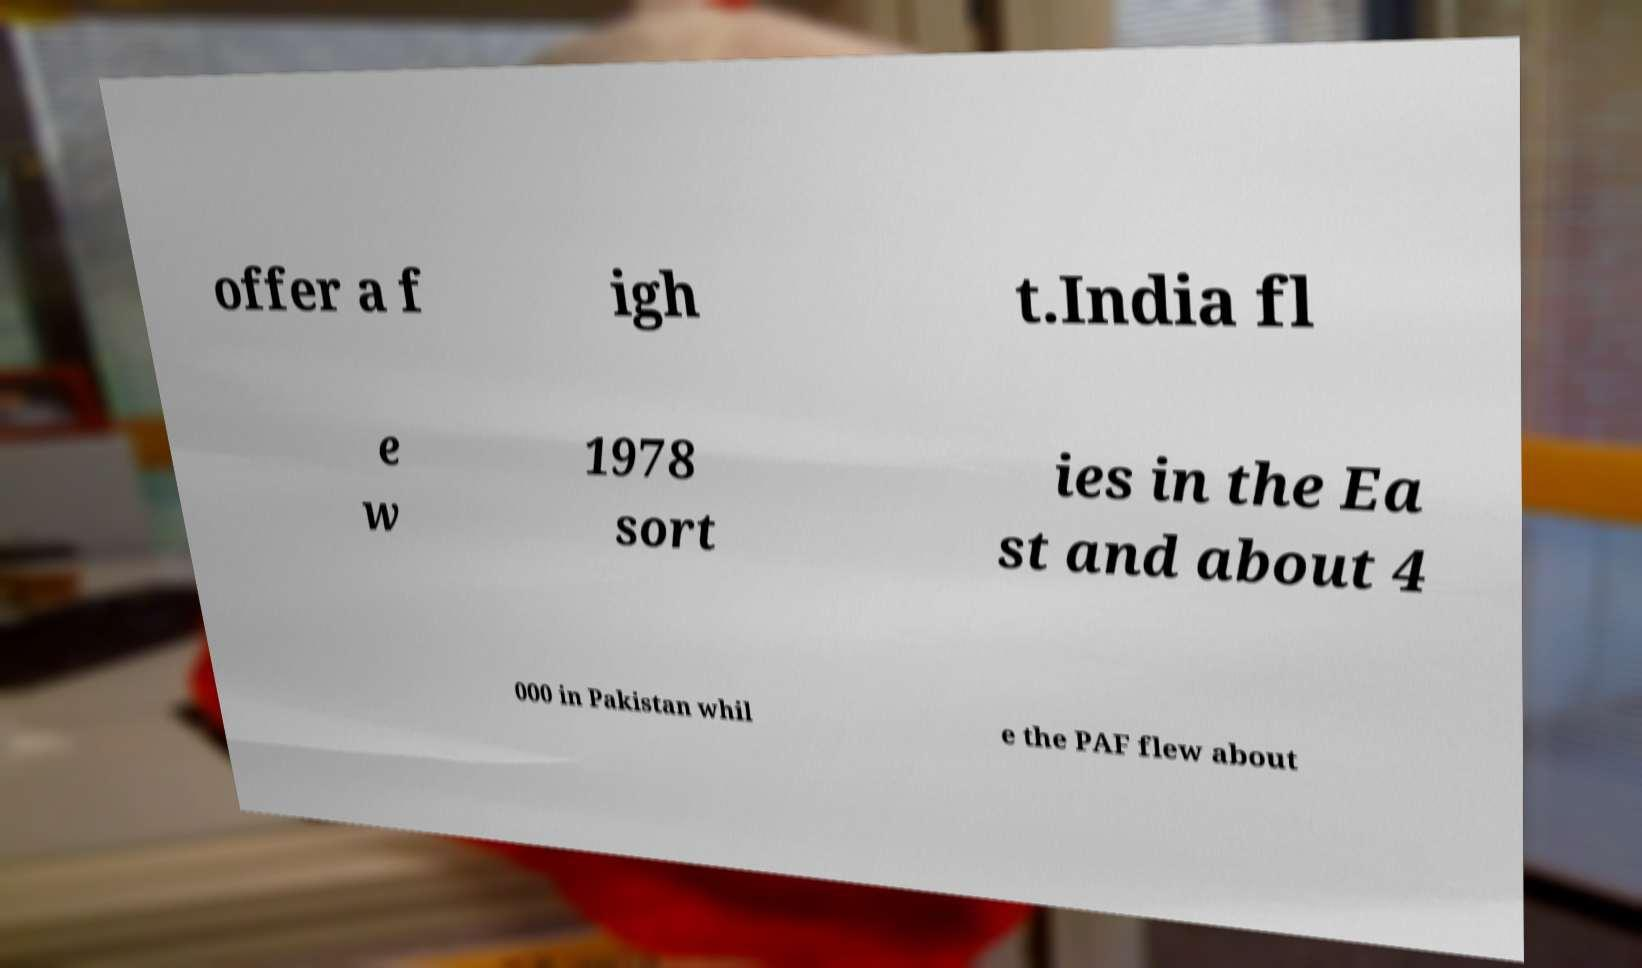There's text embedded in this image that I need extracted. Can you transcribe it verbatim? offer a f igh t.India fl e w 1978 sort ies in the Ea st and about 4 000 in Pakistan whil e the PAF flew about 